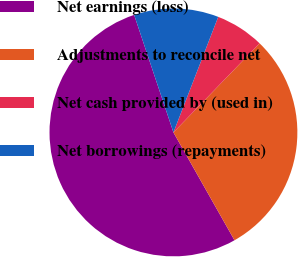Convert chart. <chart><loc_0><loc_0><loc_500><loc_500><pie_chart><fcel>Net earnings (loss)<fcel>Adjustments to reconcile net<fcel>Net cash provided by (used in)<fcel>Net borrowings (repayments)<nl><fcel>53.06%<fcel>29.57%<fcel>6.35%<fcel>11.02%<nl></chart> 